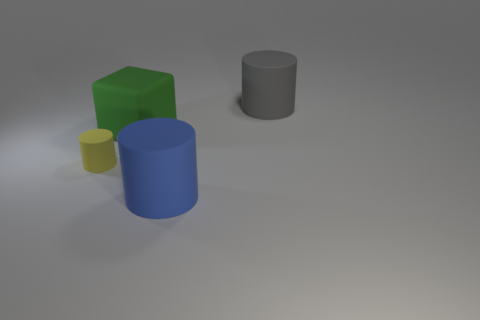Is the shape of the gray thing the same as the big green matte thing? No, the shapes are not the same. The gray object is a cylinder, while the big green object has a cuboidal shape with distinct edges and flat surfaces. Both vary in geometry and overall form. 